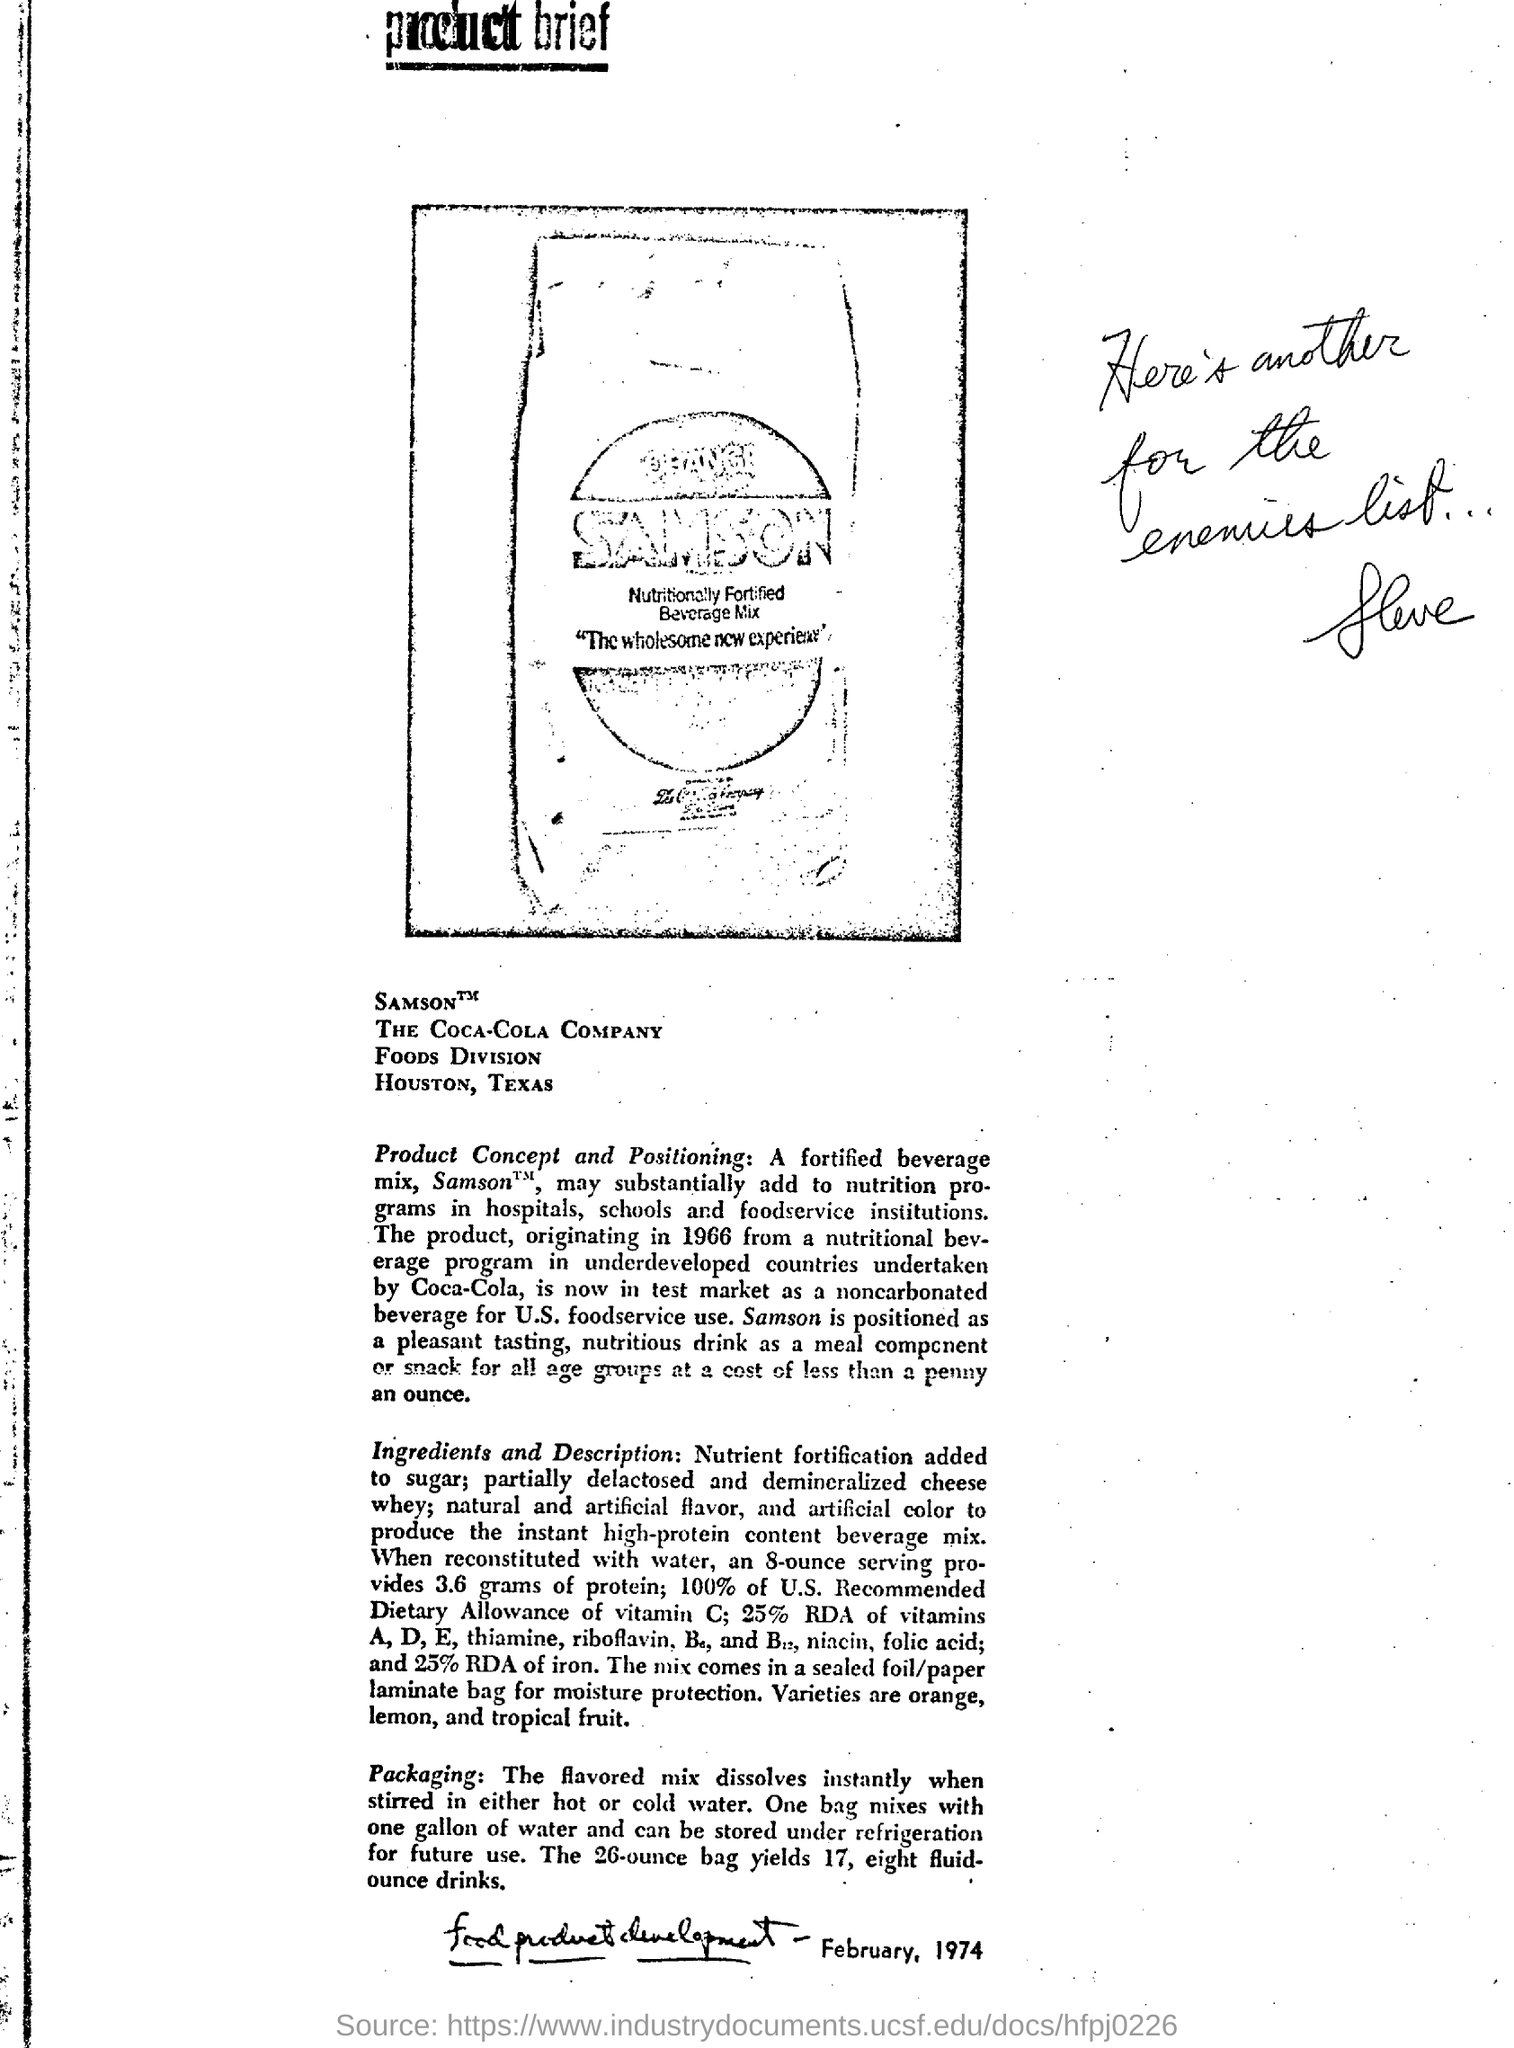Identify some key points in this picture. The Coca-Cola Company's food division is located in Houston, Texas. 